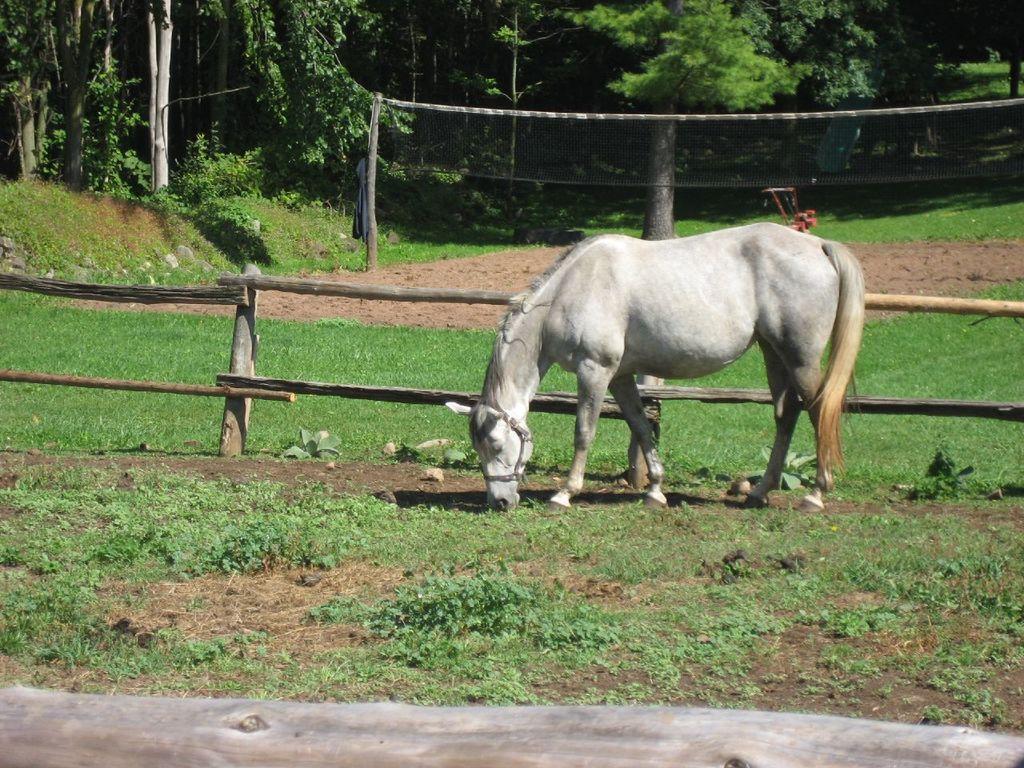Please provide a concise description of this image. In this image we can see the horse. And we can see the grass. And we can see the plants and trees. And we can see the wooden fence. 